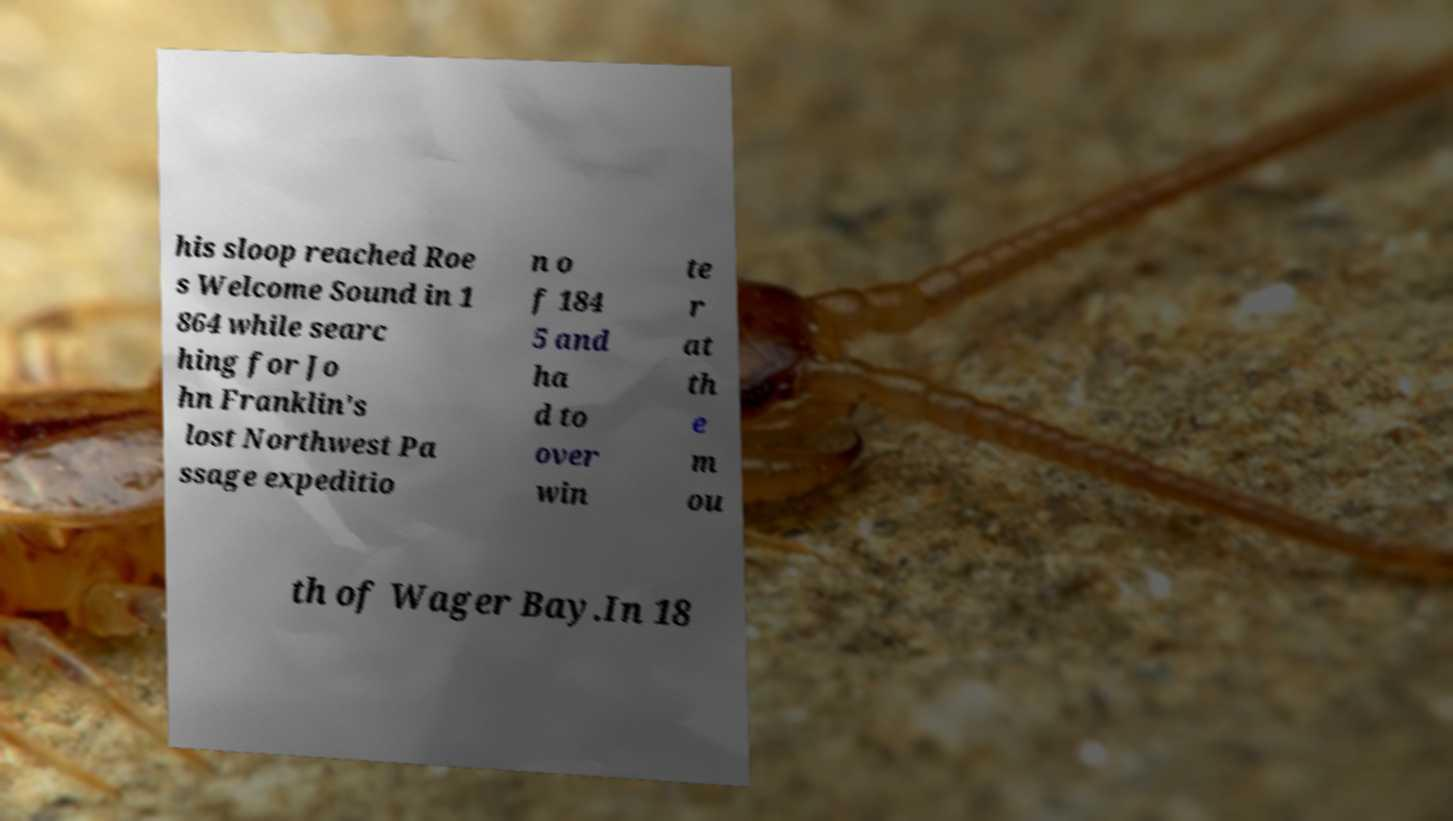I need the written content from this picture converted into text. Can you do that? his sloop reached Roe s Welcome Sound in 1 864 while searc hing for Jo hn Franklin's lost Northwest Pa ssage expeditio n o f 184 5 and ha d to over win te r at th e m ou th of Wager Bay.In 18 